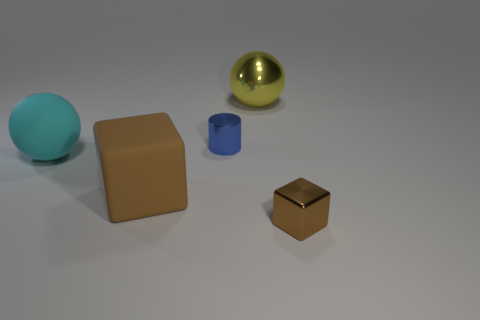How many other objects are there of the same color as the big cube?
Keep it short and to the point. 1. The big thing that is to the right of the big cyan sphere and in front of the blue object is what color?
Offer a very short reply. Brown. What number of large yellow balls are there?
Ensure brevity in your answer.  1. Is the tiny cylinder made of the same material as the big cyan ball?
Keep it short and to the point. No. There is a brown object behind the shiny thing on the right side of the sphere that is behind the cyan object; what shape is it?
Your response must be concise. Cube. Does the tiny object that is in front of the big matte ball have the same material as the small object to the left of the yellow shiny object?
Ensure brevity in your answer.  Yes. What material is the yellow object?
Your response must be concise. Metal. What number of small brown things are the same shape as the big cyan thing?
Offer a terse response. 0. There is a large object that is the same color as the metallic cube; what is it made of?
Offer a terse response. Rubber. Are there any other things that are the same shape as the blue metallic object?
Offer a very short reply. No. 